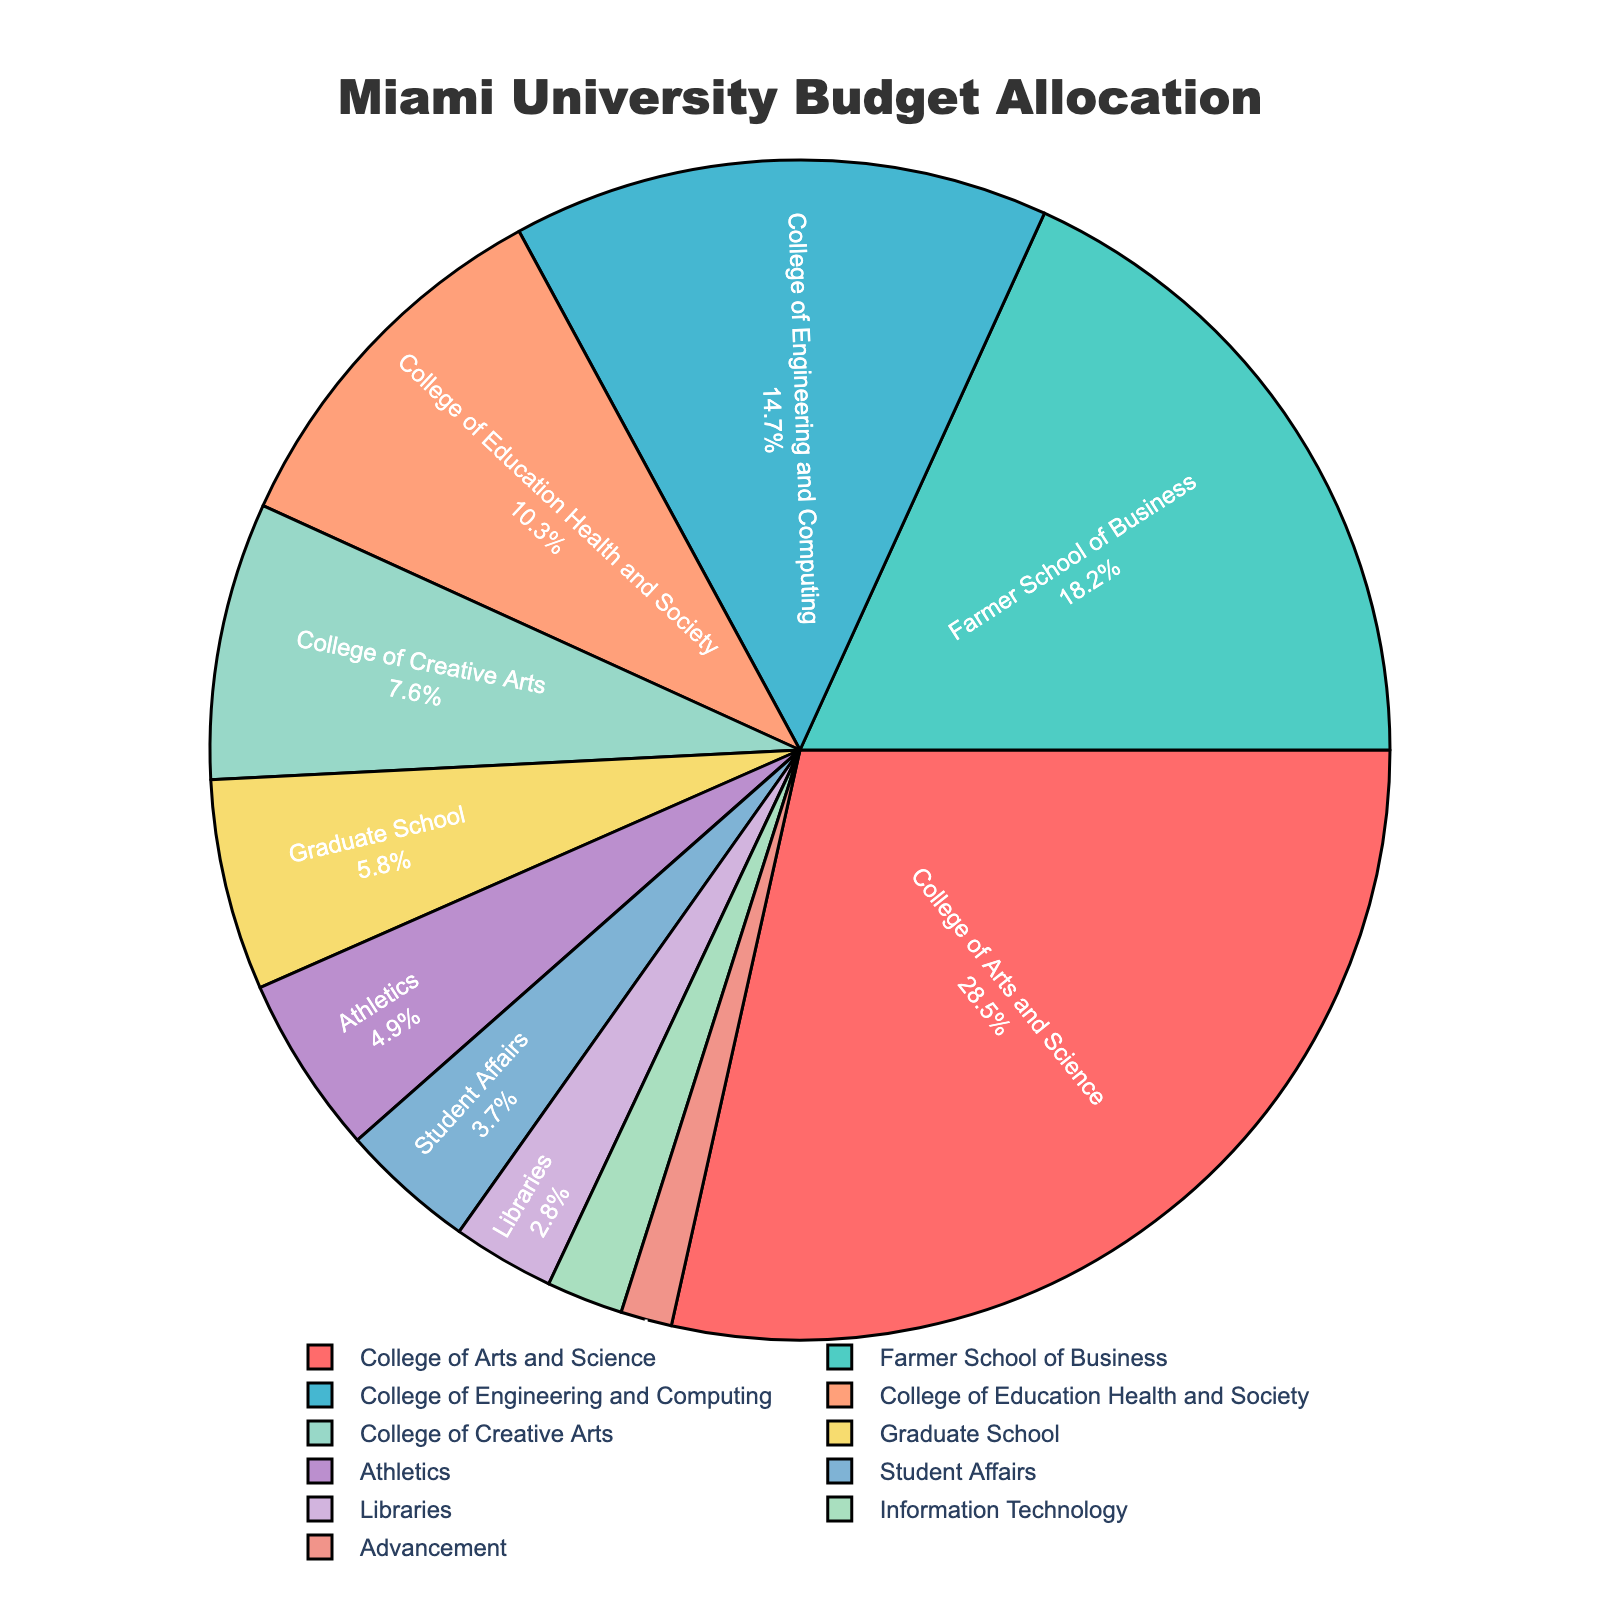Which department receives the largest share of the budget? The largest share of the budget is represented by the largest slice of the pie chart, which is the College of Arts and Science.
Answer: College of Arts and Science Which department gets the smallest allocation of the budget? The smallest slice of the pie chart represents the department with the smallest allocation, which is Advancement.
Answer: Advancement What percentage of the budget is allocated to both the College of Arts and Science and the College of Engineering and Computing combined? Add the percentages for the College of Arts and Science (28.5%) and the College of Engineering and Computing (14.7%). 28.5% + 14.7% = 43.2%
Answer: 43.2% Which department receives more budget, the Graduate School or Athletics? Compare the slices representing the Graduate School and Athletics. The Graduate School receives 5.8% and Athletics receives 4.9%, so the Graduate School receives more.
Answer: Graduate School What is the difference in budget allocation between the Farmer School of Business and Student Affairs? Subtract the percentage of Student Affairs (3.7%) from the percentage of the Farmer School of Business (18.2%). 18.2% - 3.7% = 14.5%
Answer: 14.5% How much more budget does the College of Education Health and Society receive compared to the College of Creative Arts? Subtract the percentage of the College of Creative Arts (7.6%) from the percentage of the College of Education Health and Society (10.3%). 10.3% - 7.6% = 2.7%
Answer: 2.7% What is the combined budget allocation for Athletics, Student Affairs, and Libraries? Add the percentages for Athletics (4.9%), Student Affairs (3.7%), and Libraries (2.8%). 4.9% + 3.7% + 2.8% = 11.4%
Answer: 11.4% Is the allocation for Information Technology higher or lower than the average allocation across all departments? First, calculate the average allocation: (28.5 + 18.2 + 14.7 + 10.3 + 7.6 + 5.8 + 4.9 + 3.7 + 2.8 + 2.1 + 1.4) / 11 = 8.2%. Compare this to the allocation for Information Technology (2.1%), which is lower than the average.
Answer: Lower Which department has the second-largest budget allocation, and what is its percentage? Identify the department with the second-largest slice, which is the Farmer School of Business with 18.2%.
Answer: Farmer School of Business, 18.2% 